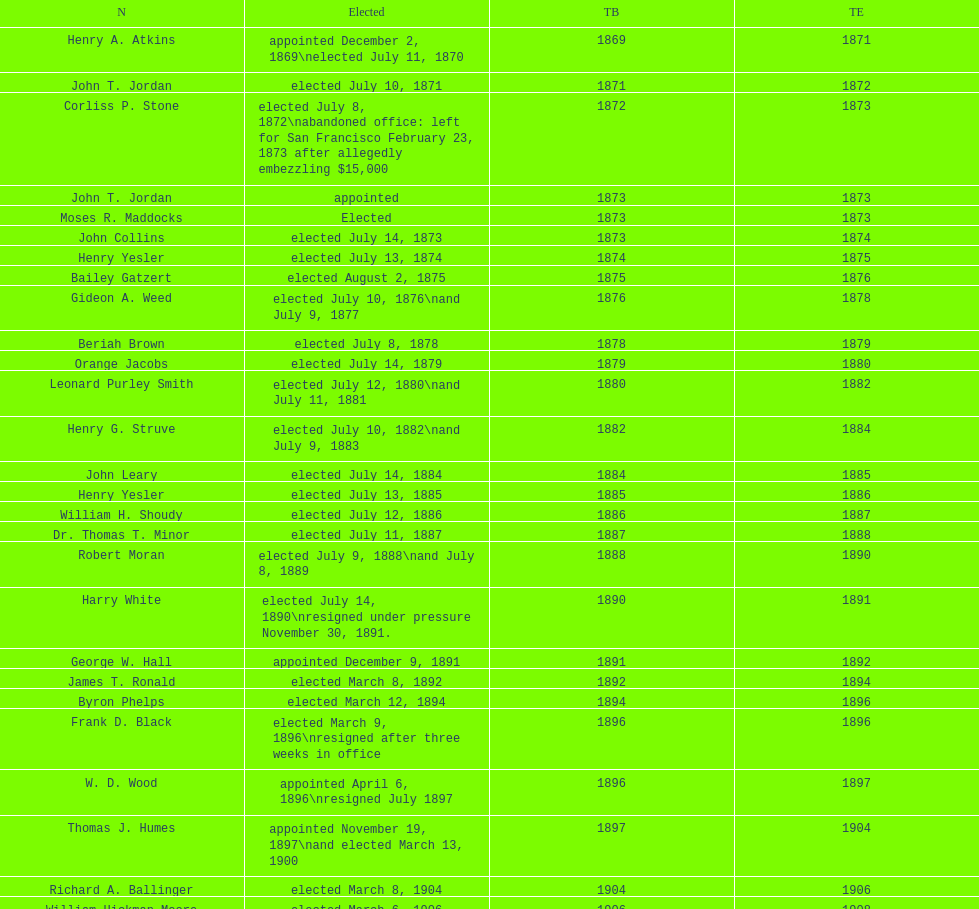Who was the only person elected in 1871? John T. Jordan. 